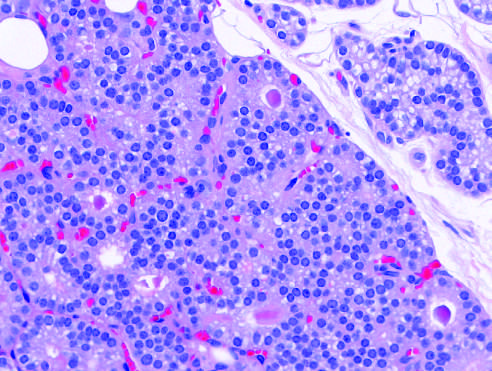does high-power detail show minimal variation in nuclear size and occasional follicle formation?
Answer the question using a single word or phrase. Yes 